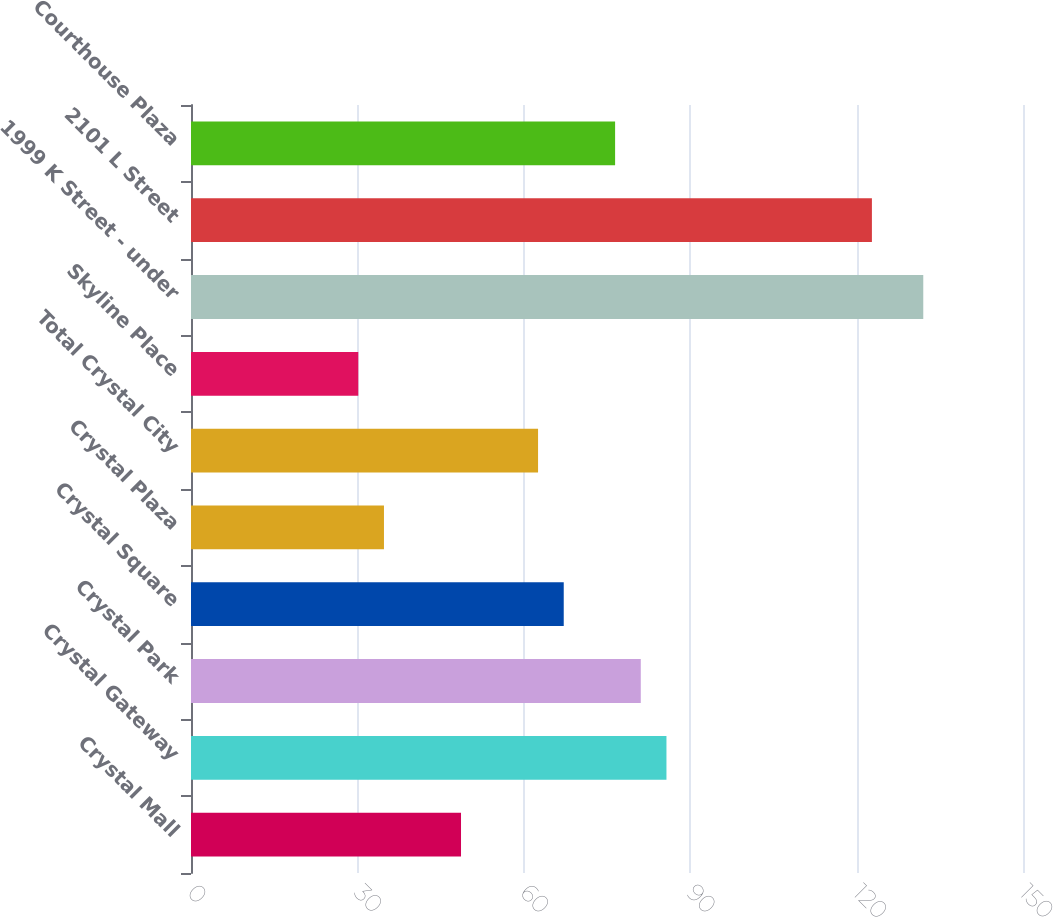<chart> <loc_0><loc_0><loc_500><loc_500><bar_chart><fcel>Crystal Mall<fcel>Crystal Gateway<fcel>Crystal Park<fcel>Crystal Square<fcel>Crystal Plaza<fcel>Total Crystal City<fcel>Skyline Place<fcel>1999 K Street - under<fcel>2101 L Street<fcel>Courthouse Plaza<nl><fcel>48.68<fcel>85.72<fcel>81.09<fcel>67.2<fcel>34.79<fcel>62.57<fcel>30.16<fcel>132.02<fcel>122.76<fcel>76.46<nl></chart> 